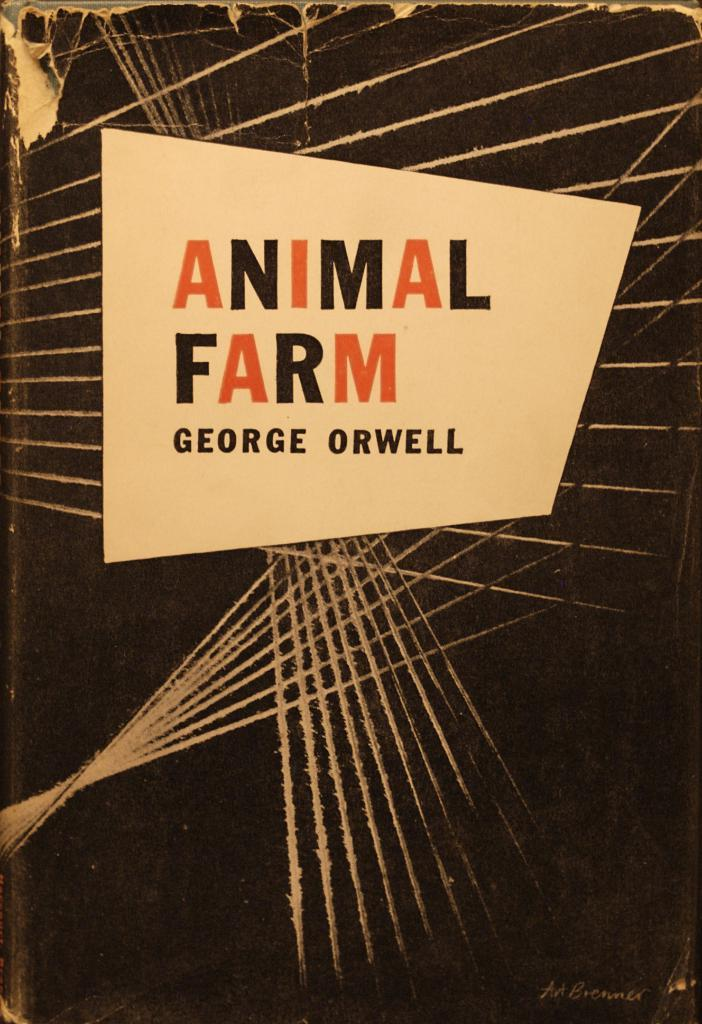<image>
Share a concise interpretation of the image provided. the cover of book Animal Farm by George Orwell 